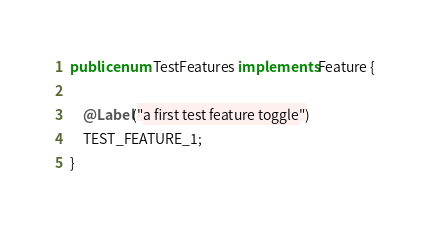<code> <loc_0><loc_0><loc_500><loc_500><_Java_>
public enum TestFeatures implements Feature {

    @Label("a first test feature toggle")
    TEST_FEATURE_1;
}
</code> 